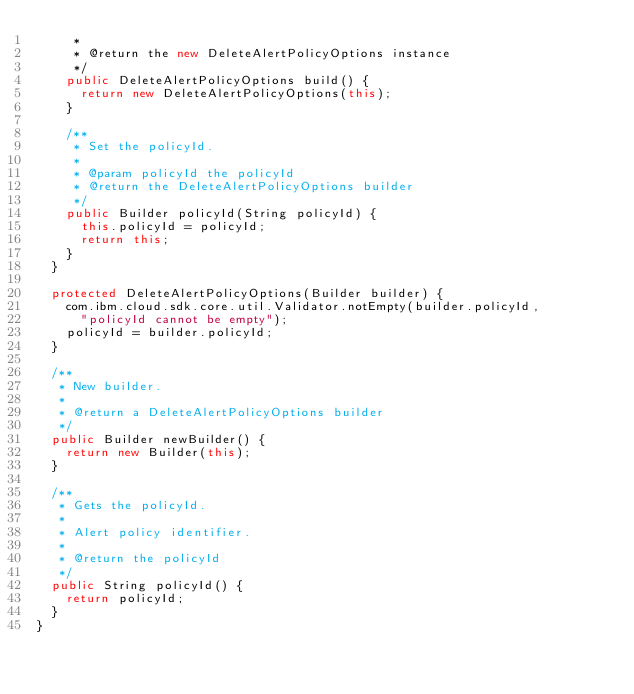<code> <loc_0><loc_0><loc_500><loc_500><_Java_>     *
     * @return the new DeleteAlertPolicyOptions instance
     */
    public DeleteAlertPolicyOptions build() {
      return new DeleteAlertPolicyOptions(this);
    }

    /**
     * Set the policyId.
     *
     * @param policyId the policyId
     * @return the DeleteAlertPolicyOptions builder
     */
    public Builder policyId(String policyId) {
      this.policyId = policyId;
      return this;
    }
  }

  protected DeleteAlertPolicyOptions(Builder builder) {
    com.ibm.cloud.sdk.core.util.Validator.notEmpty(builder.policyId,
      "policyId cannot be empty");
    policyId = builder.policyId;
  }

  /**
   * New builder.
   *
   * @return a DeleteAlertPolicyOptions builder
   */
  public Builder newBuilder() {
    return new Builder(this);
  }

  /**
   * Gets the policyId.
   *
   * Alert policy identifier.
   *
   * @return the policyId
   */
  public String policyId() {
    return policyId;
  }
}

</code> 